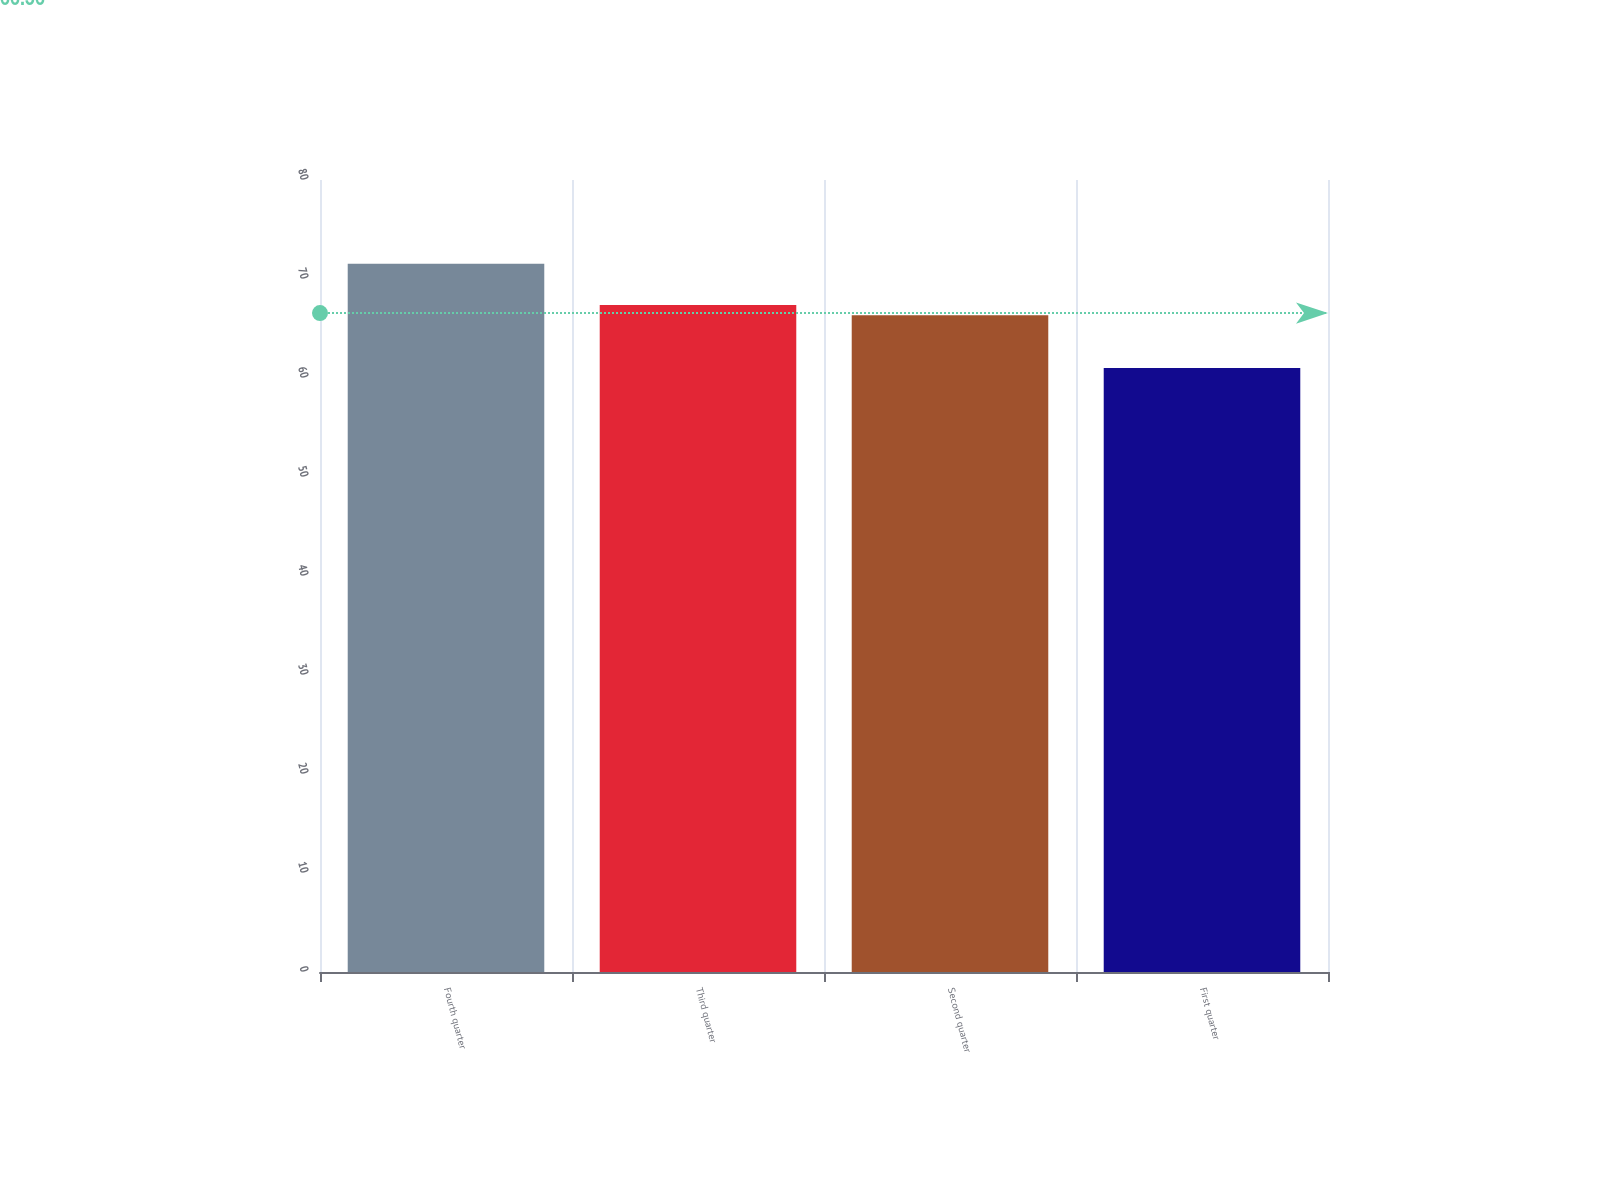Convert chart. <chart><loc_0><loc_0><loc_500><loc_500><bar_chart><fcel>Fourth quarter<fcel>Third quarter<fcel>Second quarter<fcel>First quarter<nl><fcel>71.53<fcel>67.38<fcel>66.33<fcel>61<nl></chart> 